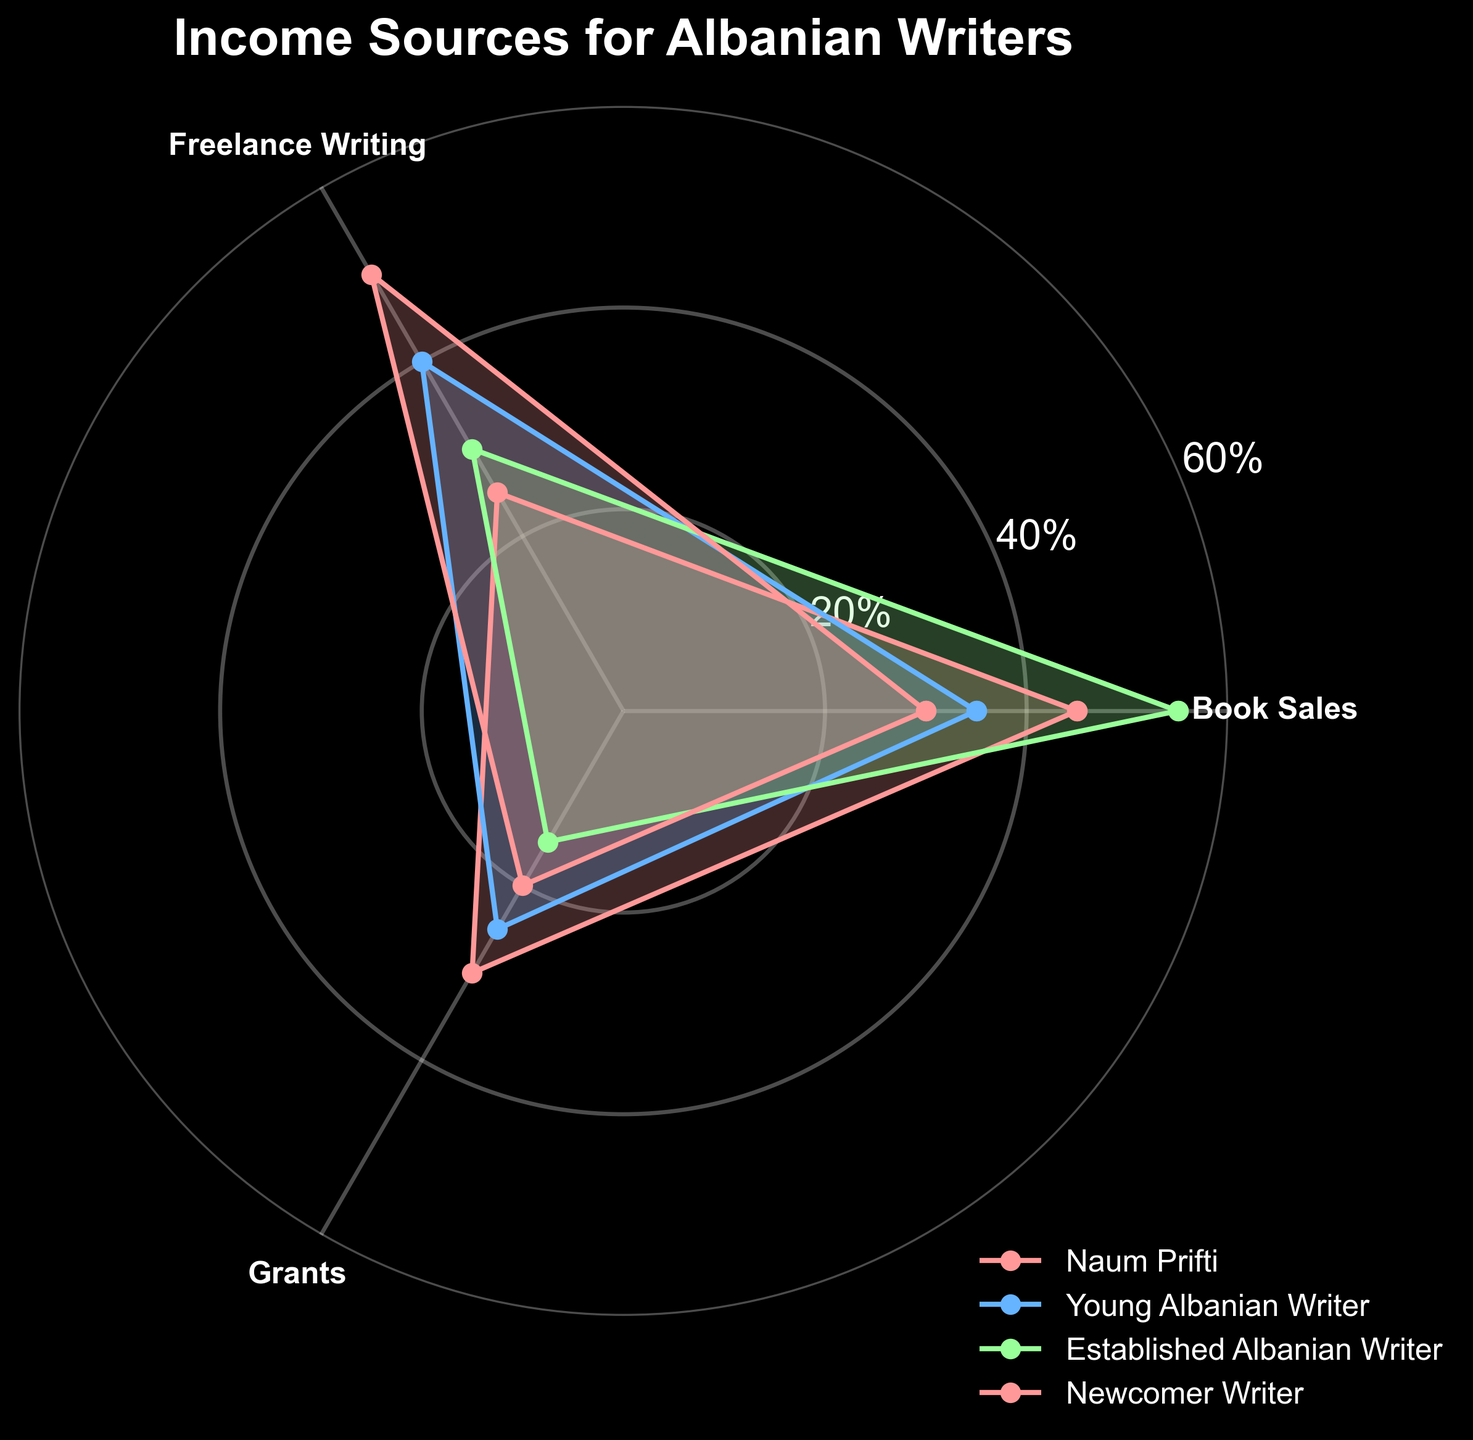What's the title of the chart? The title can be found at the top of the chart. The text says: "Income Sources for Albanian Writers".
Answer: Income Sources for Albanian Writers How many categories of income sources are represented on the chart? To determine this, look at the number of axes radiating from the center. There are three categories represented: Book Sales, Freelance Writing, and Grants.
Answer: 3 Which writer has the highest income from book sales? To identify the writer with the highest income from book sales, look for the point farthest from the center on the 'Book Sales' axis. The 'Established Albanian Writer' has the highest value at 55%.
Answer: Established Albanian Writer For which income source does "Newcomer Writer" have the highest percentage? Examine the values along each axis for the "Newcomer Writer". The highest percentage for this writer is found in 'Freelance Writing' at 50%.
Answer: Freelance Writing Compare the income percentages from freelance writing for "Naum Prifti" and "Young Albanian Writer". Who has the higher percentage and by how much? Look at the values on the 'Freelance Writing' axis for both writers. "Naum Prifti" has 25%, while "Young Albanian Writer" has 40%. The difference is 40% - 25% = 15%.
Answer: Young Albanian Writer by 15% Which writer has the most diverse distribution of income sources (i.e., the most evenly spread across all categories)? For this, identify the writer whose values across the three categories are the most similar. "Naum Prifti" has values of 45% (Book Sales), 25% (Freelance Writing), and 30% (Grants), which are fairly close to each other compared to the other writers.
Answer: Naum Prifti What is the average percentage for "Young Albanian Writer" across all income sources? Add the percentages for 'Book Sales', 'Freelance Writing', and 'Grants' for the "Young Albanian Writer" and divide by the number of categories: (35 + 40 + 25) / 3 = 100 / 3 = 33.33%.
Answer: 33.33% Which income source has the least contribution for "Established Albanian Writer"? Look at the values for each income source for "Established Albanian Writer". The smallest percentage is in 'Grants' at 15%.
Answer: Grants 